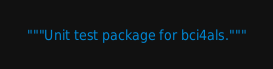Convert code to text. <code><loc_0><loc_0><loc_500><loc_500><_Python_>"""Unit test package for bci4als."""
</code> 